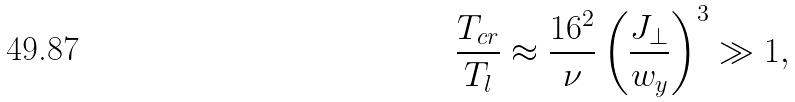Convert formula to latex. <formula><loc_0><loc_0><loc_500><loc_500>\frac { T _ { c r } } { T _ { l } } \approx \frac { 1 6 ^ { 2 } } { \nu } \left ( \frac { J _ { \perp } } { w _ { y } } \right ) ^ { 3 } \gg 1 ,</formula> 